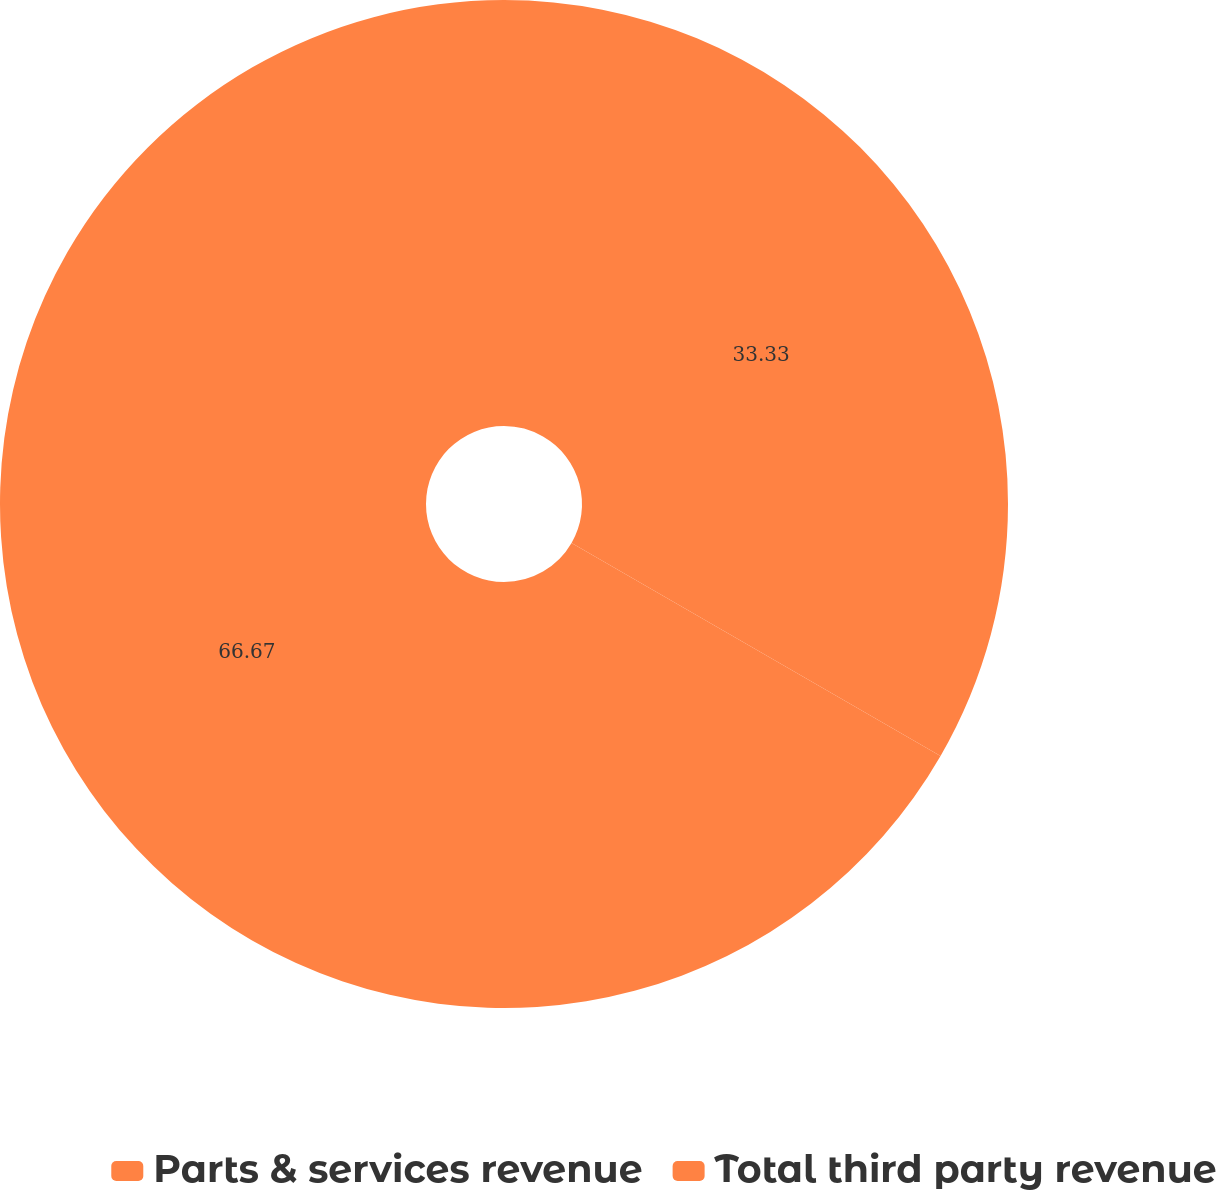Convert chart to OTSL. <chart><loc_0><loc_0><loc_500><loc_500><pie_chart><fcel>Parts & services revenue<fcel>Total third party revenue<nl><fcel>33.33%<fcel>66.67%<nl></chart> 